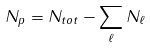<formula> <loc_0><loc_0><loc_500><loc_500>N _ { p } = N _ { t o t } - \sum _ { \ell } N _ { \ell }</formula> 